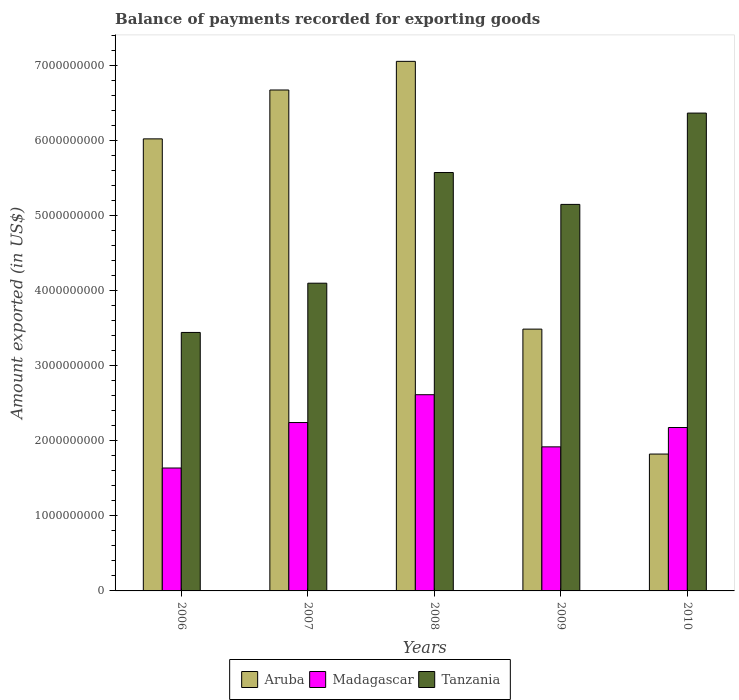Are the number of bars per tick equal to the number of legend labels?
Provide a succinct answer. Yes. Are the number of bars on each tick of the X-axis equal?
Your answer should be very brief. Yes. How many bars are there on the 5th tick from the left?
Make the answer very short. 3. How many bars are there on the 4th tick from the right?
Give a very brief answer. 3. What is the label of the 3rd group of bars from the left?
Give a very brief answer. 2008. In how many cases, is the number of bars for a given year not equal to the number of legend labels?
Your answer should be very brief. 0. What is the amount exported in Tanzania in 2008?
Ensure brevity in your answer.  5.58e+09. Across all years, what is the maximum amount exported in Tanzania?
Provide a succinct answer. 6.37e+09. Across all years, what is the minimum amount exported in Aruba?
Your answer should be compact. 1.82e+09. What is the total amount exported in Aruba in the graph?
Offer a very short reply. 2.51e+1. What is the difference between the amount exported in Tanzania in 2006 and that in 2008?
Your response must be concise. -2.13e+09. What is the difference between the amount exported in Madagascar in 2007 and the amount exported in Tanzania in 2008?
Your answer should be compact. -3.33e+09. What is the average amount exported in Madagascar per year?
Your response must be concise. 2.12e+09. In the year 2008, what is the difference between the amount exported in Aruba and amount exported in Madagascar?
Your answer should be compact. 4.44e+09. What is the ratio of the amount exported in Aruba in 2006 to that in 2009?
Make the answer very short. 1.73. Is the difference between the amount exported in Aruba in 2008 and 2010 greater than the difference between the amount exported in Madagascar in 2008 and 2010?
Ensure brevity in your answer.  Yes. What is the difference between the highest and the second highest amount exported in Aruba?
Make the answer very short. 3.82e+08. What is the difference between the highest and the lowest amount exported in Tanzania?
Provide a succinct answer. 2.92e+09. In how many years, is the amount exported in Aruba greater than the average amount exported in Aruba taken over all years?
Offer a terse response. 3. Is the sum of the amount exported in Tanzania in 2007 and 2009 greater than the maximum amount exported in Madagascar across all years?
Offer a terse response. Yes. What does the 2nd bar from the left in 2010 represents?
Keep it short and to the point. Madagascar. What does the 1st bar from the right in 2007 represents?
Make the answer very short. Tanzania. How many years are there in the graph?
Give a very brief answer. 5. Are the values on the major ticks of Y-axis written in scientific E-notation?
Give a very brief answer. No. Does the graph contain any zero values?
Offer a very short reply. No. What is the title of the graph?
Offer a very short reply. Balance of payments recorded for exporting goods. What is the label or title of the X-axis?
Your answer should be very brief. Years. What is the label or title of the Y-axis?
Offer a very short reply. Amount exported (in US$). What is the Amount exported (in US$) in Aruba in 2006?
Your response must be concise. 6.03e+09. What is the Amount exported (in US$) of Madagascar in 2006?
Offer a terse response. 1.64e+09. What is the Amount exported (in US$) in Tanzania in 2006?
Offer a very short reply. 3.45e+09. What is the Amount exported (in US$) in Aruba in 2007?
Provide a short and direct response. 6.68e+09. What is the Amount exported (in US$) of Madagascar in 2007?
Your answer should be compact. 2.24e+09. What is the Amount exported (in US$) of Tanzania in 2007?
Your answer should be compact. 4.10e+09. What is the Amount exported (in US$) of Aruba in 2008?
Keep it short and to the point. 7.06e+09. What is the Amount exported (in US$) in Madagascar in 2008?
Keep it short and to the point. 2.62e+09. What is the Amount exported (in US$) in Tanzania in 2008?
Ensure brevity in your answer.  5.58e+09. What is the Amount exported (in US$) of Aruba in 2009?
Your answer should be very brief. 3.49e+09. What is the Amount exported (in US$) in Madagascar in 2009?
Make the answer very short. 1.92e+09. What is the Amount exported (in US$) in Tanzania in 2009?
Your answer should be compact. 5.15e+09. What is the Amount exported (in US$) in Aruba in 2010?
Offer a terse response. 1.82e+09. What is the Amount exported (in US$) in Madagascar in 2010?
Your response must be concise. 2.18e+09. What is the Amount exported (in US$) of Tanzania in 2010?
Ensure brevity in your answer.  6.37e+09. Across all years, what is the maximum Amount exported (in US$) of Aruba?
Your answer should be compact. 7.06e+09. Across all years, what is the maximum Amount exported (in US$) of Madagascar?
Offer a terse response. 2.62e+09. Across all years, what is the maximum Amount exported (in US$) in Tanzania?
Offer a very short reply. 6.37e+09. Across all years, what is the minimum Amount exported (in US$) of Aruba?
Your answer should be compact. 1.82e+09. Across all years, what is the minimum Amount exported (in US$) of Madagascar?
Offer a terse response. 1.64e+09. Across all years, what is the minimum Amount exported (in US$) in Tanzania?
Your answer should be very brief. 3.45e+09. What is the total Amount exported (in US$) of Aruba in the graph?
Make the answer very short. 2.51e+1. What is the total Amount exported (in US$) in Madagascar in the graph?
Offer a very short reply. 1.06e+1. What is the total Amount exported (in US$) in Tanzania in the graph?
Offer a very short reply. 2.46e+1. What is the difference between the Amount exported (in US$) of Aruba in 2006 and that in 2007?
Offer a very short reply. -6.52e+08. What is the difference between the Amount exported (in US$) of Madagascar in 2006 and that in 2007?
Your response must be concise. -6.06e+08. What is the difference between the Amount exported (in US$) in Tanzania in 2006 and that in 2007?
Ensure brevity in your answer.  -6.57e+08. What is the difference between the Amount exported (in US$) of Aruba in 2006 and that in 2008?
Offer a terse response. -1.03e+09. What is the difference between the Amount exported (in US$) of Madagascar in 2006 and that in 2008?
Give a very brief answer. -9.77e+08. What is the difference between the Amount exported (in US$) of Tanzania in 2006 and that in 2008?
Offer a very short reply. -2.13e+09. What is the difference between the Amount exported (in US$) in Aruba in 2006 and that in 2009?
Your response must be concise. 2.54e+09. What is the difference between the Amount exported (in US$) of Madagascar in 2006 and that in 2009?
Give a very brief answer. -2.82e+08. What is the difference between the Amount exported (in US$) of Tanzania in 2006 and that in 2009?
Your response must be concise. -1.71e+09. What is the difference between the Amount exported (in US$) in Aruba in 2006 and that in 2010?
Offer a terse response. 4.20e+09. What is the difference between the Amount exported (in US$) of Madagascar in 2006 and that in 2010?
Make the answer very short. -5.40e+08. What is the difference between the Amount exported (in US$) of Tanzania in 2006 and that in 2010?
Your answer should be compact. -2.92e+09. What is the difference between the Amount exported (in US$) of Aruba in 2007 and that in 2008?
Your answer should be compact. -3.82e+08. What is the difference between the Amount exported (in US$) of Madagascar in 2007 and that in 2008?
Your response must be concise. -3.71e+08. What is the difference between the Amount exported (in US$) in Tanzania in 2007 and that in 2008?
Provide a succinct answer. -1.48e+09. What is the difference between the Amount exported (in US$) of Aruba in 2007 and that in 2009?
Ensure brevity in your answer.  3.19e+09. What is the difference between the Amount exported (in US$) of Madagascar in 2007 and that in 2009?
Offer a very short reply. 3.24e+08. What is the difference between the Amount exported (in US$) of Tanzania in 2007 and that in 2009?
Provide a succinct answer. -1.05e+09. What is the difference between the Amount exported (in US$) in Aruba in 2007 and that in 2010?
Ensure brevity in your answer.  4.85e+09. What is the difference between the Amount exported (in US$) of Madagascar in 2007 and that in 2010?
Offer a very short reply. 6.62e+07. What is the difference between the Amount exported (in US$) of Tanzania in 2007 and that in 2010?
Provide a short and direct response. -2.27e+09. What is the difference between the Amount exported (in US$) of Aruba in 2008 and that in 2009?
Make the answer very short. 3.57e+09. What is the difference between the Amount exported (in US$) of Madagascar in 2008 and that in 2009?
Make the answer very short. 6.95e+08. What is the difference between the Amount exported (in US$) in Tanzania in 2008 and that in 2009?
Provide a succinct answer. 4.25e+08. What is the difference between the Amount exported (in US$) in Aruba in 2008 and that in 2010?
Provide a succinct answer. 5.24e+09. What is the difference between the Amount exported (in US$) of Madagascar in 2008 and that in 2010?
Provide a succinct answer. 4.37e+08. What is the difference between the Amount exported (in US$) in Tanzania in 2008 and that in 2010?
Keep it short and to the point. -7.92e+08. What is the difference between the Amount exported (in US$) of Aruba in 2009 and that in 2010?
Provide a succinct answer. 1.67e+09. What is the difference between the Amount exported (in US$) of Madagascar in 2009 and that in 2010?
Your answer should be very brief. -2.58e+08. What is the difference between the Amount exported (in US$) of Tanzania in 2009 and that in 2010?
Offer a very short reply. -1.22e+09. What is the difference between the Amount exported (in US$) of Aruba in 2006 and the Amount exported (in US$) of Madagascar in 2007?
Provide a succinct answer. 3.78e+09. What is the difference between the Amount exported (in US$) of Aruba in 2006 and the Amount exported (in US$) of Tanzania in 2007?
Your answer should be very brief. 1.92e+09. What is the difference between the Amount exported (in US$) in Madagascar in 2006 and the Amount exported (in US$) in Tanzania in 2007?
Your response must be concise. -2.46e+09. What is the difference between the Amount exported (in US$) of Aruba in 2006 and the Amount exported (in US$) of Madagascar in 2008?
Your answer should be very brief. 3.41e+09. What is the difference between the Amount exported (in US$) of Aruba in 2006 and the Amount exported (in US$) of Tanzania in 2008?
Provide a succinct answer. 4.49e+08. What is the difference between the Amount exported (in US$) of Madagascar in 2006 and the Amount exported (in US$) of Tanzania in 2008?
Ensure brevity in your answer.  -3.94e+09. What is the difference between the Amount exported (in US$) in Aruba in 2006 and the Amount exported (in US$) in Madagascar in 2009?
Your response must be concise. 4.11e+09. What is the difference between the Amount exported (in US$) in Aruba in 2006 and the Amount exported (in US$) in Tanzania in 2009?
Your answer should be very brief. 8.74e+08. What is the difference between the Amount exported (in US$) of Madagascar in 2006 and the Amount exported (in US$) of Tanzania in 2009?
Your answer should be very brief. -3.51e+09. What is the difference between the Amount exported (in US$) in Aruba in 2006 and the Amount exported (in US$) in Madagascar in 2010?
Provide a short and direct response. 3.85e+09. What is the difference between the Amount exported (in US$) in Aruba in 2006 and the Amount exported (in US$) in Tanzania in 2010?
Provide a short and direct response. -3.44e+08. What is the difference between the Amount exported (in US$) in Madagascar in 2006 and the Amount exported (in US$) in Tanzania in 2010?
Keep it short and to the point. -4.73e+09. What is the difference between the Amount exported (in US$) of Aruba in 2007 and the Amount exported (in US$) of Madagascar in 2008?
Ensure brevity in your answer.  4.06e+09. What is the difference between the Amount exported (in US$) of Aruba in 2007 and the Amount exported (in US$) of Tanzania in 2008?
Your answer should be very brief. 1.10e+09. What is the difference between the Amount exported (in US$) of Madagascar in 2007 and the Amount exported (in US$) of Tanzania in 2008?
Your answer should be very brief. -3.33e+09. What is the difference between the Amount exported (in US$) of Aruba in 2007 and the Amount exported (in US$) of Madagascar in 2009?
Give a very brief answer. 4.76e+09. What is the difference between the Amount exported (in US$) of Aruba in 2007 and the Amount exported (in US$) of Tanzania in 2009?
Provide a short and direct response. 1.53e+09. What is the difference between the Amount exported (in US$) in Madagascar in 2007 and the Amount exported (in US$) in Tanzania in 2009?
Provide a succinct answer. -2.91e+09. What is the difference between the Amount exported (in US$) in Aruba in 2007 and the Amount exported (in US$) in Madagascar in 2010?
Make the answer very short. 4.50e+09. What is the difference between the Amount exported (in US$) in Aruba in 2007 and the Amount exported (in US$) in Tanzania in 2010?
Your answer should be compact. 3.08e+08. What is the difference between the Amount exported (in US$) of Madagascar in 2007 and the Amount exported (in US$) of Tanzania in 2010?
Your answer should be compact. -4.13e+09. What is the difference between the Amount exported (in US$) in Aruba in 2008 and the Amount exported (in US$) in Madagascar in 2009?
Your answer should be very brief. 5.14e+09. What is the difference between the Amount exported (in US$) in Aruba in 2008 and the Amount exported (in US$) in Tanzania in 2009?
Your response must be concise. 1.91e+09. What is the difference between the Amount exported (in US$) in Madagascar in 2008 and the Amount exported (in US$) in Tanzania in 2009?
Your response must be concise. -2.54e+09. What is the difference between the Amount exported (in US$) in Aruba in 2008 and the Amount exported (in US$) in Madagascar in 2010?
Keep it short and to the point. 4.88e+09. What is the difference between the Amount exported (in US$) in Aruba in 2008 and the Amount exported (in US$) in Tanzania in 2010?
Your response must be concise. 6.90e+08. What is the difference between the Amount exported (in US$) of Madagascar in 2008 and the Amount exported (in US$) of Tanzania in 2010?
Provide a succinct answer. -3.75e+09. What is the difference between the Amount exported (in US$) of Aruba in 2009 and the Amount exported (in US$) of Madagascar in 2010?
Offer a terse response. 1.31e+09. What is the difference between the Amount exported (in US$) of Aruba in 2009 and the Amount exported (in US$) of Tanzania in 2010?
Provide a short and direct response. -2.88e+09. What is the difference between the Amount exported (in US$) of Madagascar in 2009 and the Amount exported (in US$) of Tanzania in 2010?
Provide a short and direct response. -4.45e+09. What is the average Amount exported (in US$) of Aruba per year?
Make the answer very short. 5.02e+09. What is the average Amount exported (in US$) in Madagascar per year?
Keep it short and to the point. 2.12e+09. What is the average Amount exported (in US$) in Tanzania per year?
Ensure brevity in your answer.  4.93e+09. In the year 2006, what is the difference between the Amount exported (in US$) of Aruba and Amount exported (in US$) of Madagascar?
Keep it short and to the point. 4.39e+09. In the year 2006, what is the difference between the Amount exported (in US$) in Aruba and Amount exported (in US$) in Tanzania?
Offer a terse response. 2.58e+09. In the year 2006, what is the difference between the Amount exported (in US$) in Madagascar and Amount exported (in US$) in Tanzania?
Your answer should be compact. -1.81e+09. In the year 2007, what is the difference between the Amount exported (in US$) in Aruba and Amount exported (in US$) in Madagascar?
Give a very brief answer. 4.43e+09. In the year 2007, what is the difference between the Amount exported (in US$) of Aruba and Amount exported (in US$) of Tanzania?
Your response must be concise. 2.58e+09. In the year 2007, what is the difference between the Amount exported (in US$) of Madagascar and Amount exported (in US$) of Tanzania?
Provide a succinct answer. -1.86e+09. In the year 2008, what is the difference between the Amount exported (in US$) of Aruba and Amount exported (in US$) of Madagascar?
Ensure brevity in your answer.  4.44e+09. In the year 2008, what is the difference between the Amount exported (in US$) in Aruba and Amount exported (in US$) in Tanzania?
Offer a very short reply. 1.48e+09. In the year 2008, what is the difference between the Amount exported (in US$) in Madagascar and Amount exported (in US$) in Tanzania?
Give a very brief answer. -2.96e+09. In the year 2009, what is the difference between the Amount exported (in US$) in Aruba and Amount exported (in US$) in Madagascar?
Offer a very short reply. 1.57e+09. In the year 2009, what is the difference between the Amount exported (in US$) of Aruba and Amount exported (in US$) of Tanzania?
Give a very brief answer. -1.66e+09. In the year 2009, what is the difference between the Amount exported (in US$) of Madagascar and Amount exported (in US$) of Tanzania?
Give a very brief answer. -3.23e+09. In the year 2010, what is the difference between the Amount exported (in US$) in Aruba and Amount exported (in US$) in Madagascar?
Ensure brevity in your answer.  -3.54e+08. In the year 2010, what is the difference between the Amount exported (in US$) of Aruba and Amount exported (in US$) of Tanzania?
Your answer should be very brief. -4.55e+09. In the year 2010, what is the difference between the Amount exported (in US$) of Madagascar and Amount exported (in US$) of Tanzania?
Make the answer very short. -4.19e+09. What is the ratio of the Amount exported (in US$) in Aruba in 2006 to that in 2007?
Your answer should be very brief. 0.9. What is the ratio of the Amount exported (in US$) in Madagascar in 2006 to that in 2007?
Give a very brief answer. 0.73. What is the ratio of the Amount exported (in US$) of Tanzania in 2006 to that in 2007?
Offer a terse response. 0.84. What is the ratio of the Amount exported (in US$) of Aruba in 2006 to that in 2008?
Keep it short and to the point. 0.85. What is the ratio of the Amount exported (in US$) of Madagascar in 2006 to that in 2008?
Keep it short and to the point. 0.63. What is the ratio of the Amount exported (in US$) in Tanzania in 2006 to that in 2008?
Make the answer very short. 0.62. What is the ratio of the Amount exported (in US$) in Aruba in 2006 to that in 2009?
Offer a very short reply. 1.73. What is the ratio of the Amount exported (in US$) of Madagascar in 2006 to that in 2009?
Offer a very short reply. 0.85. What is the ratio of the Amount exported (in US$) of Tanzania in 2006 to that in 2009?
Offer a terse response. 0.67. What is the ratio of the Amount exported (in US$) of Aruba in 2006 to that in 2010?
Make the answer very short. 3.3. What is the ratio of the Amount exported (in US$) of Madagascar in 2006 to that in 2010?
Offer a very short reply. 0.75. What is the ratio of the Amount exported (in US$) in Tanzania in 2006 to that in 2010?
Make the answer very short. 0.54. What is the ratio of the Amount exported (in US$) in Aruba in 2007 to that in 2008?
Give a very brief answer. 0.95. What is the ratio of the Amount exported (in US$) of Madagascar in 2007 to that in 2008?
Offer a terse response. 0.86. What is the ratio of the Amount exported (in US$) in Tanzania in 2007 to that in 2008?
Offer a terse response. 0.74. What is the ratio of the Amount exported (in US$) in Aruba in 2007 to that in 2009?
Make the answer very short. 1.91. What is the ratio of the Amount exported (in US$) in Madagascar in 2007 to that in 2009?
Keep it short and to the point. 1.17. What is the ratio of the Amount exported (in US$) in Tanzania in 2007 to that in 2009?
Ensure brevity in your answer.  0.8. What is the ratio of the Amount exported (in US$) in Aruba in 2007 to that in 2010?
Offer a very short reply. 3.66. What is the ratio of the Amount exported (in US$) in Madagascar in 2007 to that in 2010?
Keep it short and to the point. 1.03. What is the ratio of the Amount exported (in US$) in Tanzania in 2007 to that in 2010?
Your answer should be compact. 0.64. What is the ratio of the Amount exported (in US$) in Aruba in 2008 to that in 2009?
Your answer should be compact. 2.02. What is the ratio of the Amount exported (in US$) in Madagascar in 2008 to that in 2009?
Offer a terse response. 1.36. What is the ratio of the Amount exported (in US$) of Tanzania in 2008 to that in 2009?
Ensure brevity in your answer.  1.08. What is the ratio of the Amount exported (in US$) of Aruba in 2008 to that in 2010?
Make the answer very short. 3.87. What is the ratio of the Amount exported (in US$) in Madagascar in 2008 to that in 2010?
Provide a succinct answer. 1.2. What is the ratio of the Amount exported (in US$) in Tanzania in 2008 to that in 2010?
Your answer should be compact. 0.88. What is the ratio of the Amount exported (in US$) in Aruba in 2009 to that in 2010?
Make the answer very short. 1.91. What is the ratio of the Amount exported (in US$) of Madagascar in 2009 to that in 2010?
Your answer should be compact. 0.88. What is the ratio of the Amount exported (in US$) of Tanzania in 2009 to that in 2010?
Keep it short and to the point. 0.81. What is the difference between the highest and the second highest Amount exported (in US$) in Aruba?
Offer a very short reply. 3.82e+08. What is the difference between the highest and the second highest Amount exported (in US$) in Madagascar?
Make the answer very short. 3.71e+08. What is the difference between the highest and the second highest Amount exported (in US$) of Tanzania?
Provide a succinct answer. 7.92e+08. What is the difference between the highest and the lowest Amount exported (in US$) in Aruba?
Your answer should be compact. 5.24e+09. What is the difference between the highest and the lowest Amount exported (in US$) of Madagascar?
Offer a very short reply. 9.77e+08. What is the difference between the highest and the lowest Amount exported (in US$) of Tanzania?
Give a very brief answer. 2.92e+09. 